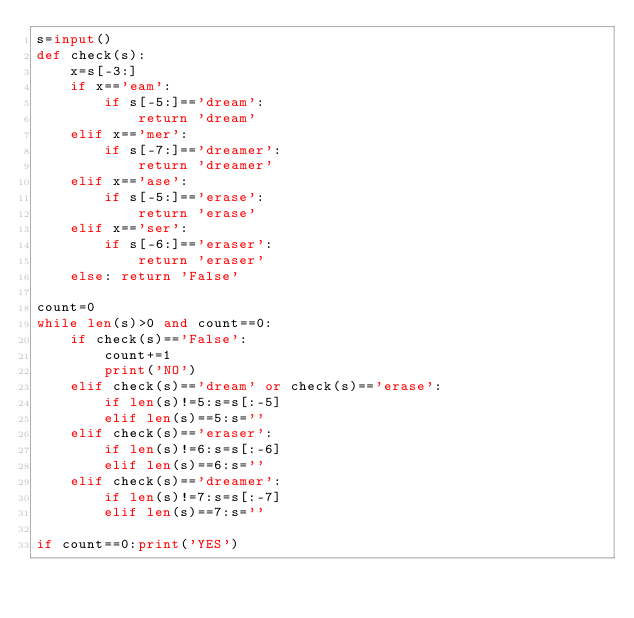<code> <loc_0><loc_0><loc_500><loc_500><_Python_>s=input()
def check(s):
    x=s[-3:]
    if x=='eam':
        if s[-5:]=='dream':
            return 'dream'
    elif x=='mer':
        if s[-7:]=='dreamer':
            return 'dreamer'
    elif x=='ase':
        if s[-5:]=='erase':
            return 'erase'
    elif x=='ser':
        if s[-6:]=='eraser':
            return 'eraser'
    else: return 'False'

count=0
while len(s)>0 and count==0:
    if check(s)=='False':
        count+=1
        print('NO')
    elif check(s)=='dream' or check(s)=='erase':
        if len(s)!=5:s=s[:-5]
        elif len(s)==5:s=''
    elif check(s)=='eraser':
        if len(s)!=6:s=s[:-6]
        elif len(s)==6:s=''
    elif check(s)=='dreamer':
        if len(s)!=7:s=s[:-7]
        elif len(s)==7:s=''

if count==0:print('YES')</code> 